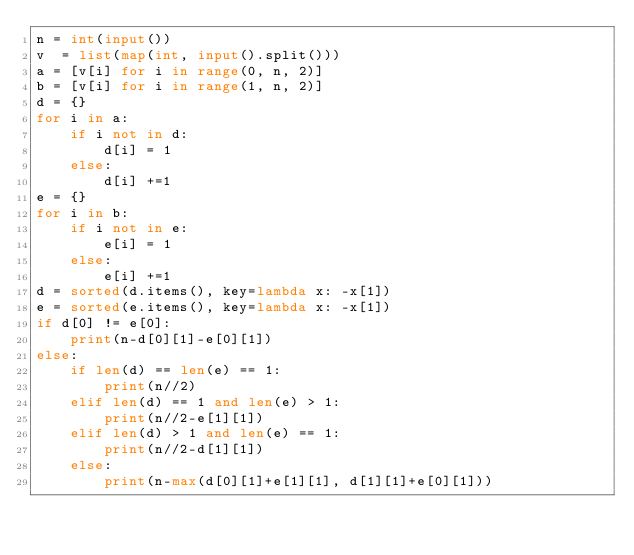Convert code to text. <code><loc_0><loc_0><loc_500><loc_500><_Python_>n = int(input())
v  = list(map(int, input().split()))
a = [v[i] for i in range(0, n, 2)]
b = [v[i] for i in range(1, n, 2)]
d = {}
for i in a:
    if i not in d:
        d[i] = 1
    else:
        d[i] +=1
e = {}
for i in b:
    if i not in e:
        e[i] = 1
    else:
        e[i] +=1
d = sorted(d.items(), key=lambda x: -x[1])
e = sorted(e.items(), key=lambda x: -x[1])
if d[0] != e[0]:
    print(n-d[0][1]-e[0][1])
else:
    if len(d) == len(e) == 1:
        print(n//2)
    elif len(d) == 1 and len(e) > 1:
        print(n//2-e[1][1])
    elif len(d) > 1 and len(e) == 1:
        print(n//2-d[1][1])
    else:
        print(n-max(d[0][1]+e[1][1], d[1][1]+e[0][1]))
</code> 